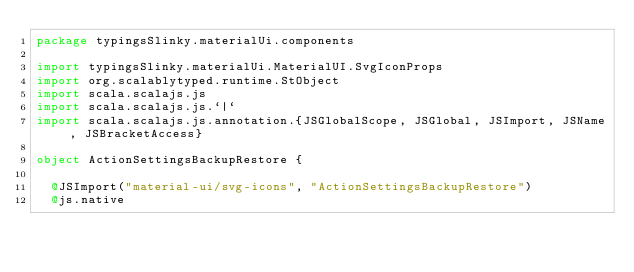Convert code to text. <code><loc_0><loc_0><loc_500><loc_500><_Scala_>package typingsSlinky.materialUi.components

import typingsSlinky.materialUi.MaterialUI.SvgIconProps
import org.scalablytyped.runtime.StObject
import scala.scalajs.js
import scala.scalajs.js.`|`
import scala.scalajs.js.annotation.{JSGlobalScope, JSGlobal, JSImport, JSName, JSBracketAccess}

object ActionSettingsBackupRestore {
  
  @JSImport("material-ui/svg-icons", "ActionSettingsBackupRestore")
  @js.native</code> 